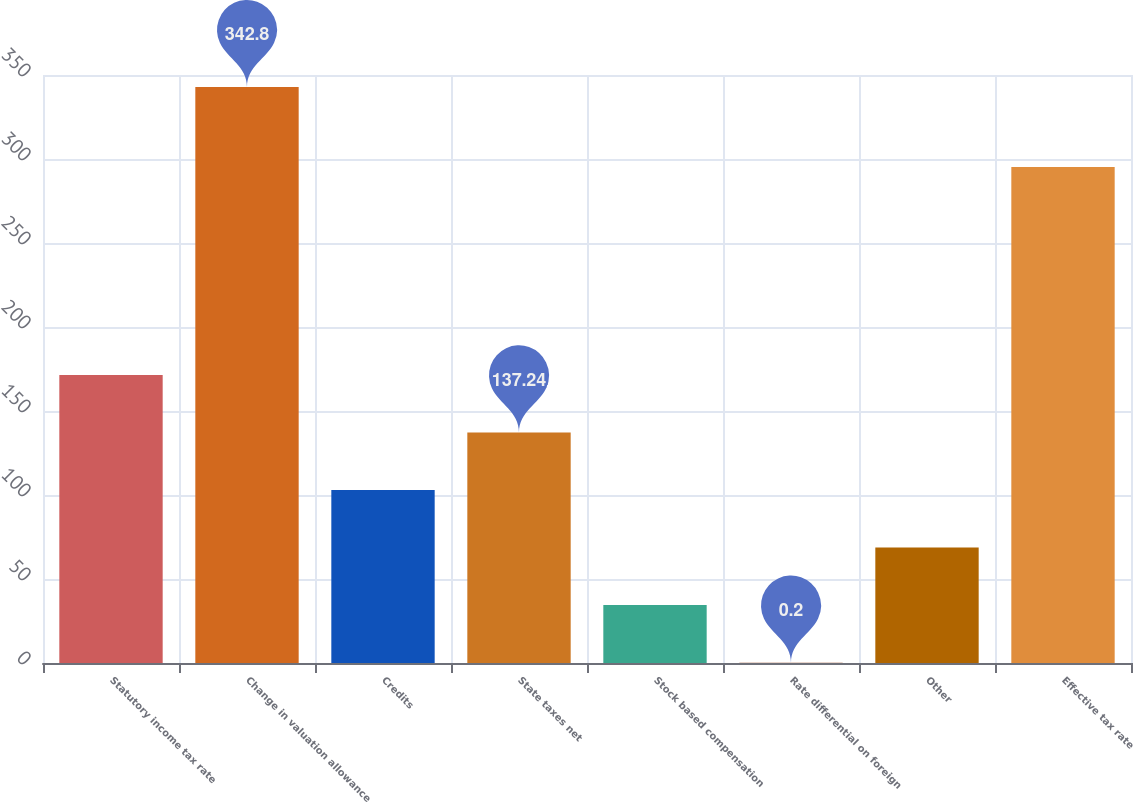Convert chart. <chart><loc_0><loc_0><loc_500><loc_500><bar_chart><fcel>Statutory income tax rate<fcel>Change in valuation allowance<fcel>Credits<fcel>State taxes net<fcel>Stock based compensation<fcel>Rate differential on foreign<fcel>Other<fcel>Effective tax rate<nl><fcel>171.5<fcel>342.8<fcel>102.98<fcel>137.24<fcel>34.46<fcel>0.2<fcel>68.72<fcel>295.2<nl></chart> 